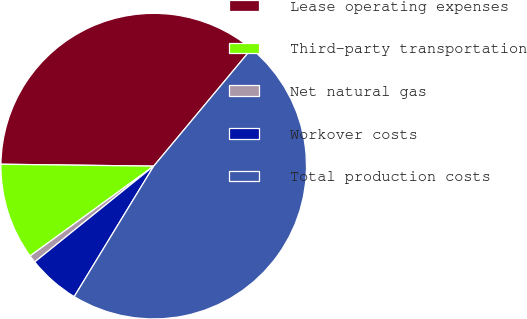Convert chart. <chart><loc_0><loc_0><loc_500><loc_500><pie_chart><fcel>Lease operating expenses<fcel>Third-party transportation<fcel>Net natural gas<fcel>Workover costs<fcel>Total production costs<nl><fcel>35.86%<fcel>10.2%<fcel>0.79%<fcel>5.5%<fcel>47.65%<nl></chart> 